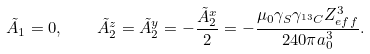<formula> <loc_0><loc_0><loc_500><loc_500>\tilde { A } _ { 1 } = 0 , \quad \tilde { A } _ { 2 } ^ { z } = \tilde { A } _ { 2 } ^ { y } = - \frac { \tilde { A } _ { 2 } ^ { x } } { 2 } = - \frac { \mu _ { 0 } \gamma _ { S } \gamma _ { ^ { 1 3 } C } Z _ { e f f } ^ { 3 } } { 2 4 0 \pi a _ { 0 } ^ { 3 } } .</formula> 